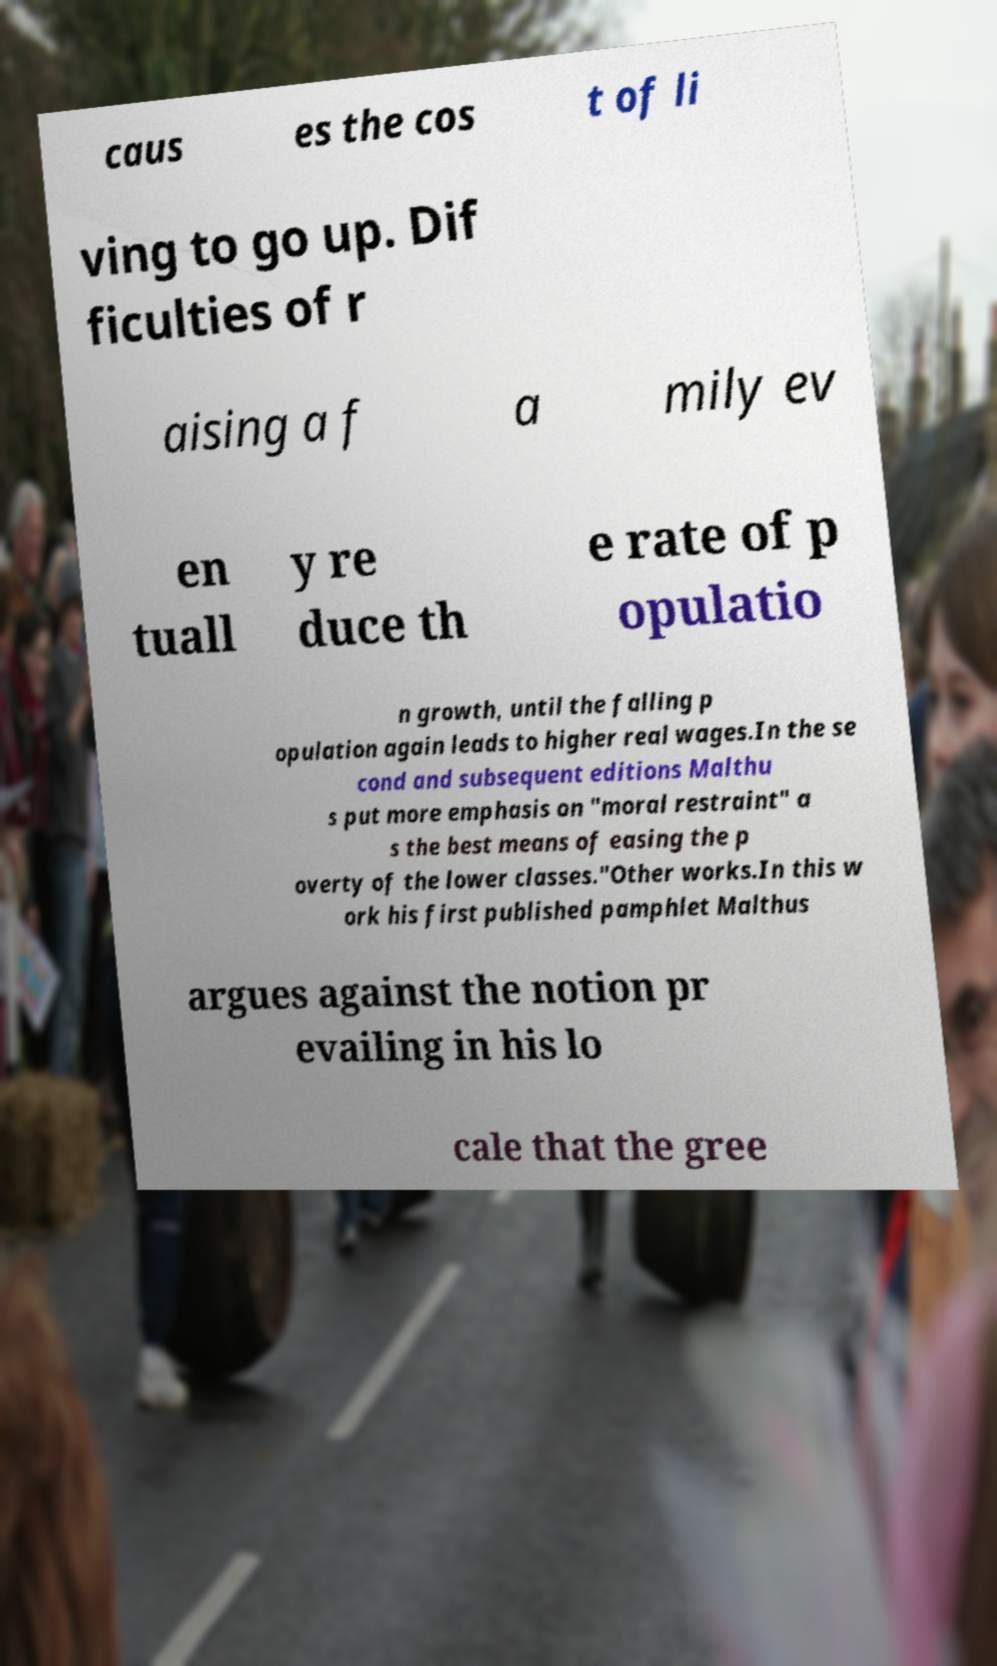Can you accurately transcribe the text from the provided image for me? caus es the cos t of li ving to go up. Dif ficulties of r aising a f a mily ev en tuall y re duce th e rate of p opulatio n growth, until the falling p opulation again leads to higher real wages.In the se cond and subsequent editions Malthu s put more emphasis on "moral restraint" a s the best means of easing the p overty of the lower classes."Other works.In this w ork his first published pamphlet Malthus argues against the notion pr evailing in his lo cale that the gree 